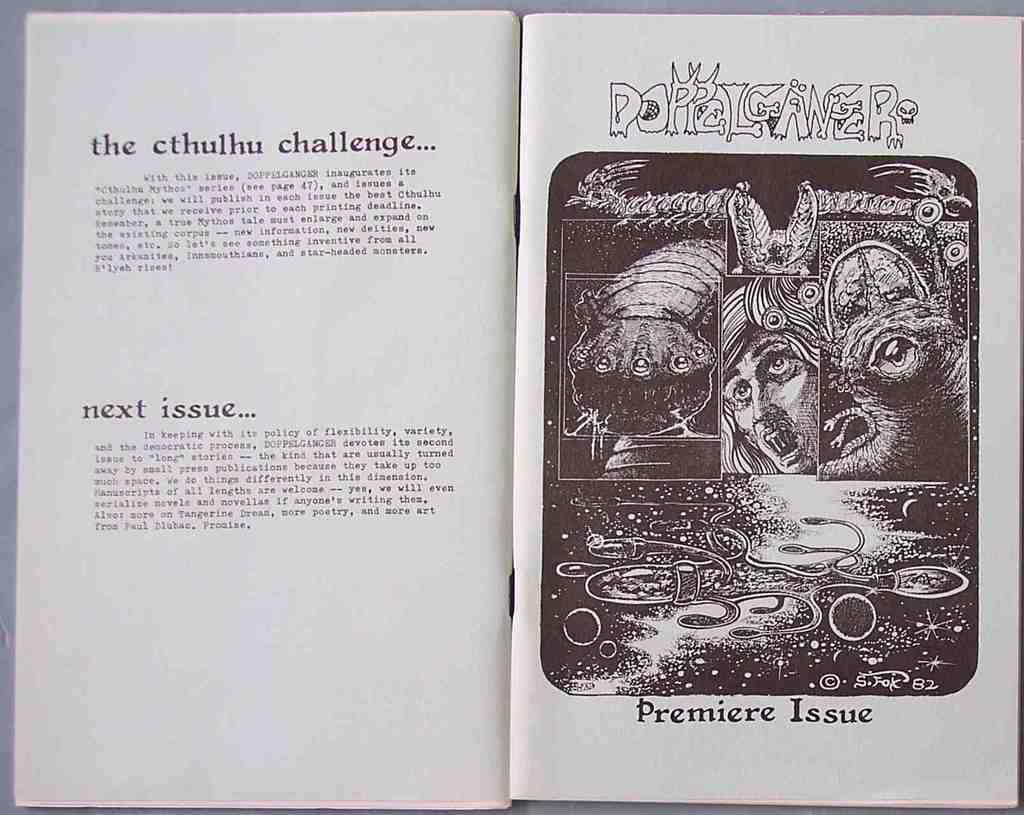<image>
Create a compact narrative representing the image presented. The premier issue of a book called Doppelganger that focuses on Cthulhu mythos stories. 